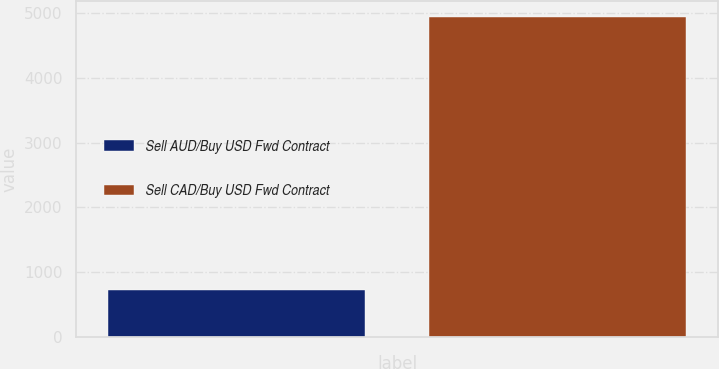<chart> <loc_0><loc_0><loc_500><loc_500><bar_chart><fcel>Sell AUD/Buy USD Fwd Contract<fcel>Sell CAD/Buy USD Fwd Contract<nl><fcel>724<fcel>4940<nl></chart> 